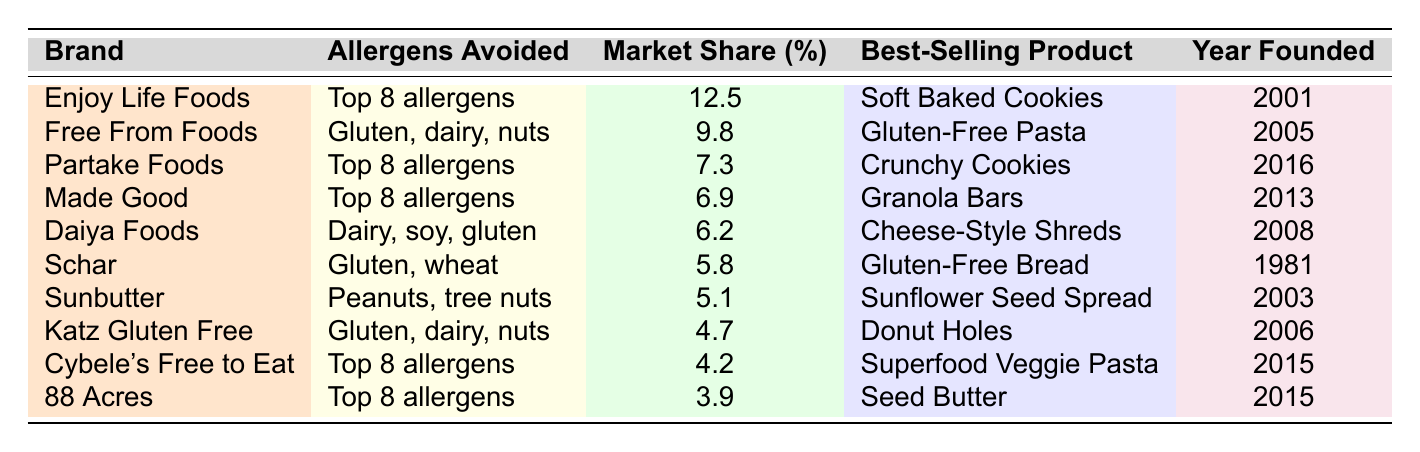What is the best-selling product of Enjoy Life Foods? You can find the brand "Enjoy Life Foods" and look at the corresponding row under the "Best-Selling Product" column, which shows "Soft Baked Cookies".
Answer: Soft Baked Cookies Which brand has the highest market share and what is that percentage? Looking through the "Market Share (%)" column, the highest value is 12.5, which corresponds to the brand "Enjoy Life Foods".
Answer: 12.5% How many brands avoid the top 8 allergens? By checking the "Allergens Avoided" column, the brands that mention "Top 8 allergens" are Enjoy Life Foods, Partake Foods, Made Good, Cybele's Free to Eat, and 88 Acres. Counting these, we find there are 5 brands.
Answer: 5 What allergens does Daiya Foods avoid? In the row for "Daiya Foods," under the "Allergens Avoided" column, it states "Dairy, soy, gluten".
Answer: Dairy, soy, gluten What is the average market share of the brands that avoid gluten? The brands that avoid gluten are Free From Foods, Daiya Foods, Schar, Katz Gluten Free, and 88 Acres. Their market shares are 9.8, 6.2, 5.8, 4.7, and 3.9 respectively. The sum is (9.8 + 6.2 + 5.8 + 4.7 + 3.9) = 30.4 and dividing by 5 gives an average of 30.4 / 5 = 6.08.
Answer: 6.08% Which brand was founded most recently and what year was it founded? The last row to look at shows that "Partake Foods" was founded in 2016, which is the most recent year represented in the table.
Answer: 2016 Is it true that Schar avoids dairy? In the "Allergens Avoided" column for "Schar," it specifically states "Gluten, wheat," which indicates no dairy is avoided. Thus, the statement is false.
Answer: False What is the total market share of brands that have been founded after 2010? The brands founded after 2010 are Partake Foods (7.3), Made Good (6.9), Sunbutter (5.1), Katz Gluten Free (4.7), Cybele's Free to Eat (4.2), and 88 Acres (3.9). Adding these shares gives (7.3 + 6.9 + 5.1 + 4.7 + 4.2 + 3.9) = 32.1%.
Answer: 32.1% How many brands have been founded prior to 2000? In the table, only one brand—Schar—was founded in 1981, which is before 2000.
Answer: 1 What is the market share difference between Enjoy Life Foods and Free From Foods? The market share of Enjoy Life Foods is 12.5% and for Free From Foods, it is 9.8%. The difference is calculated as 12.5 - 9.8 = 2.7%.
Answer: 2.7% 